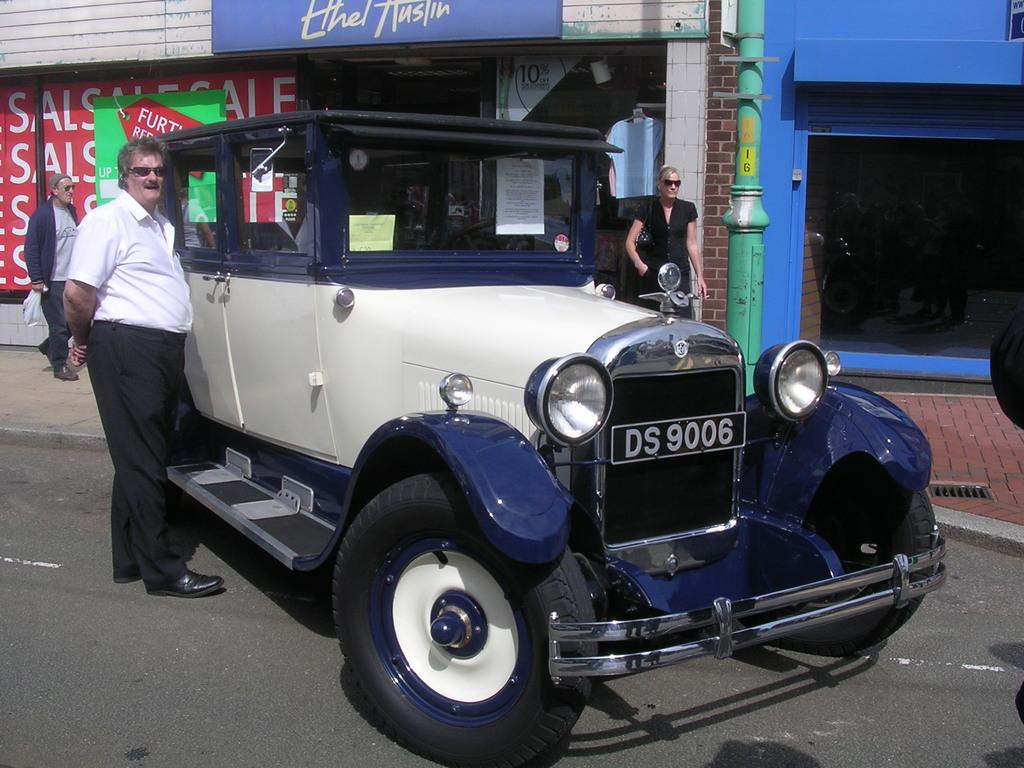What is the main subject of the image? There is a vehicle in the image. What colors can be seen on the vehicle? The vehicle is white and blue in color. Where is the vehicle located? The vehicle is on the road. Is there anyone near the vehicle? Yes, there is a person standing beside the vehicle. What can be seen in the background of the image? There is a store visible in the background of the image. What type of society is depicted in the image? The image does not depict a society; it features a vehicle, a person, and a store. Can you tell me a joke that is related to the goose in the image? There is no goose present in the image, so it is not possible to tell a joke related to it. 